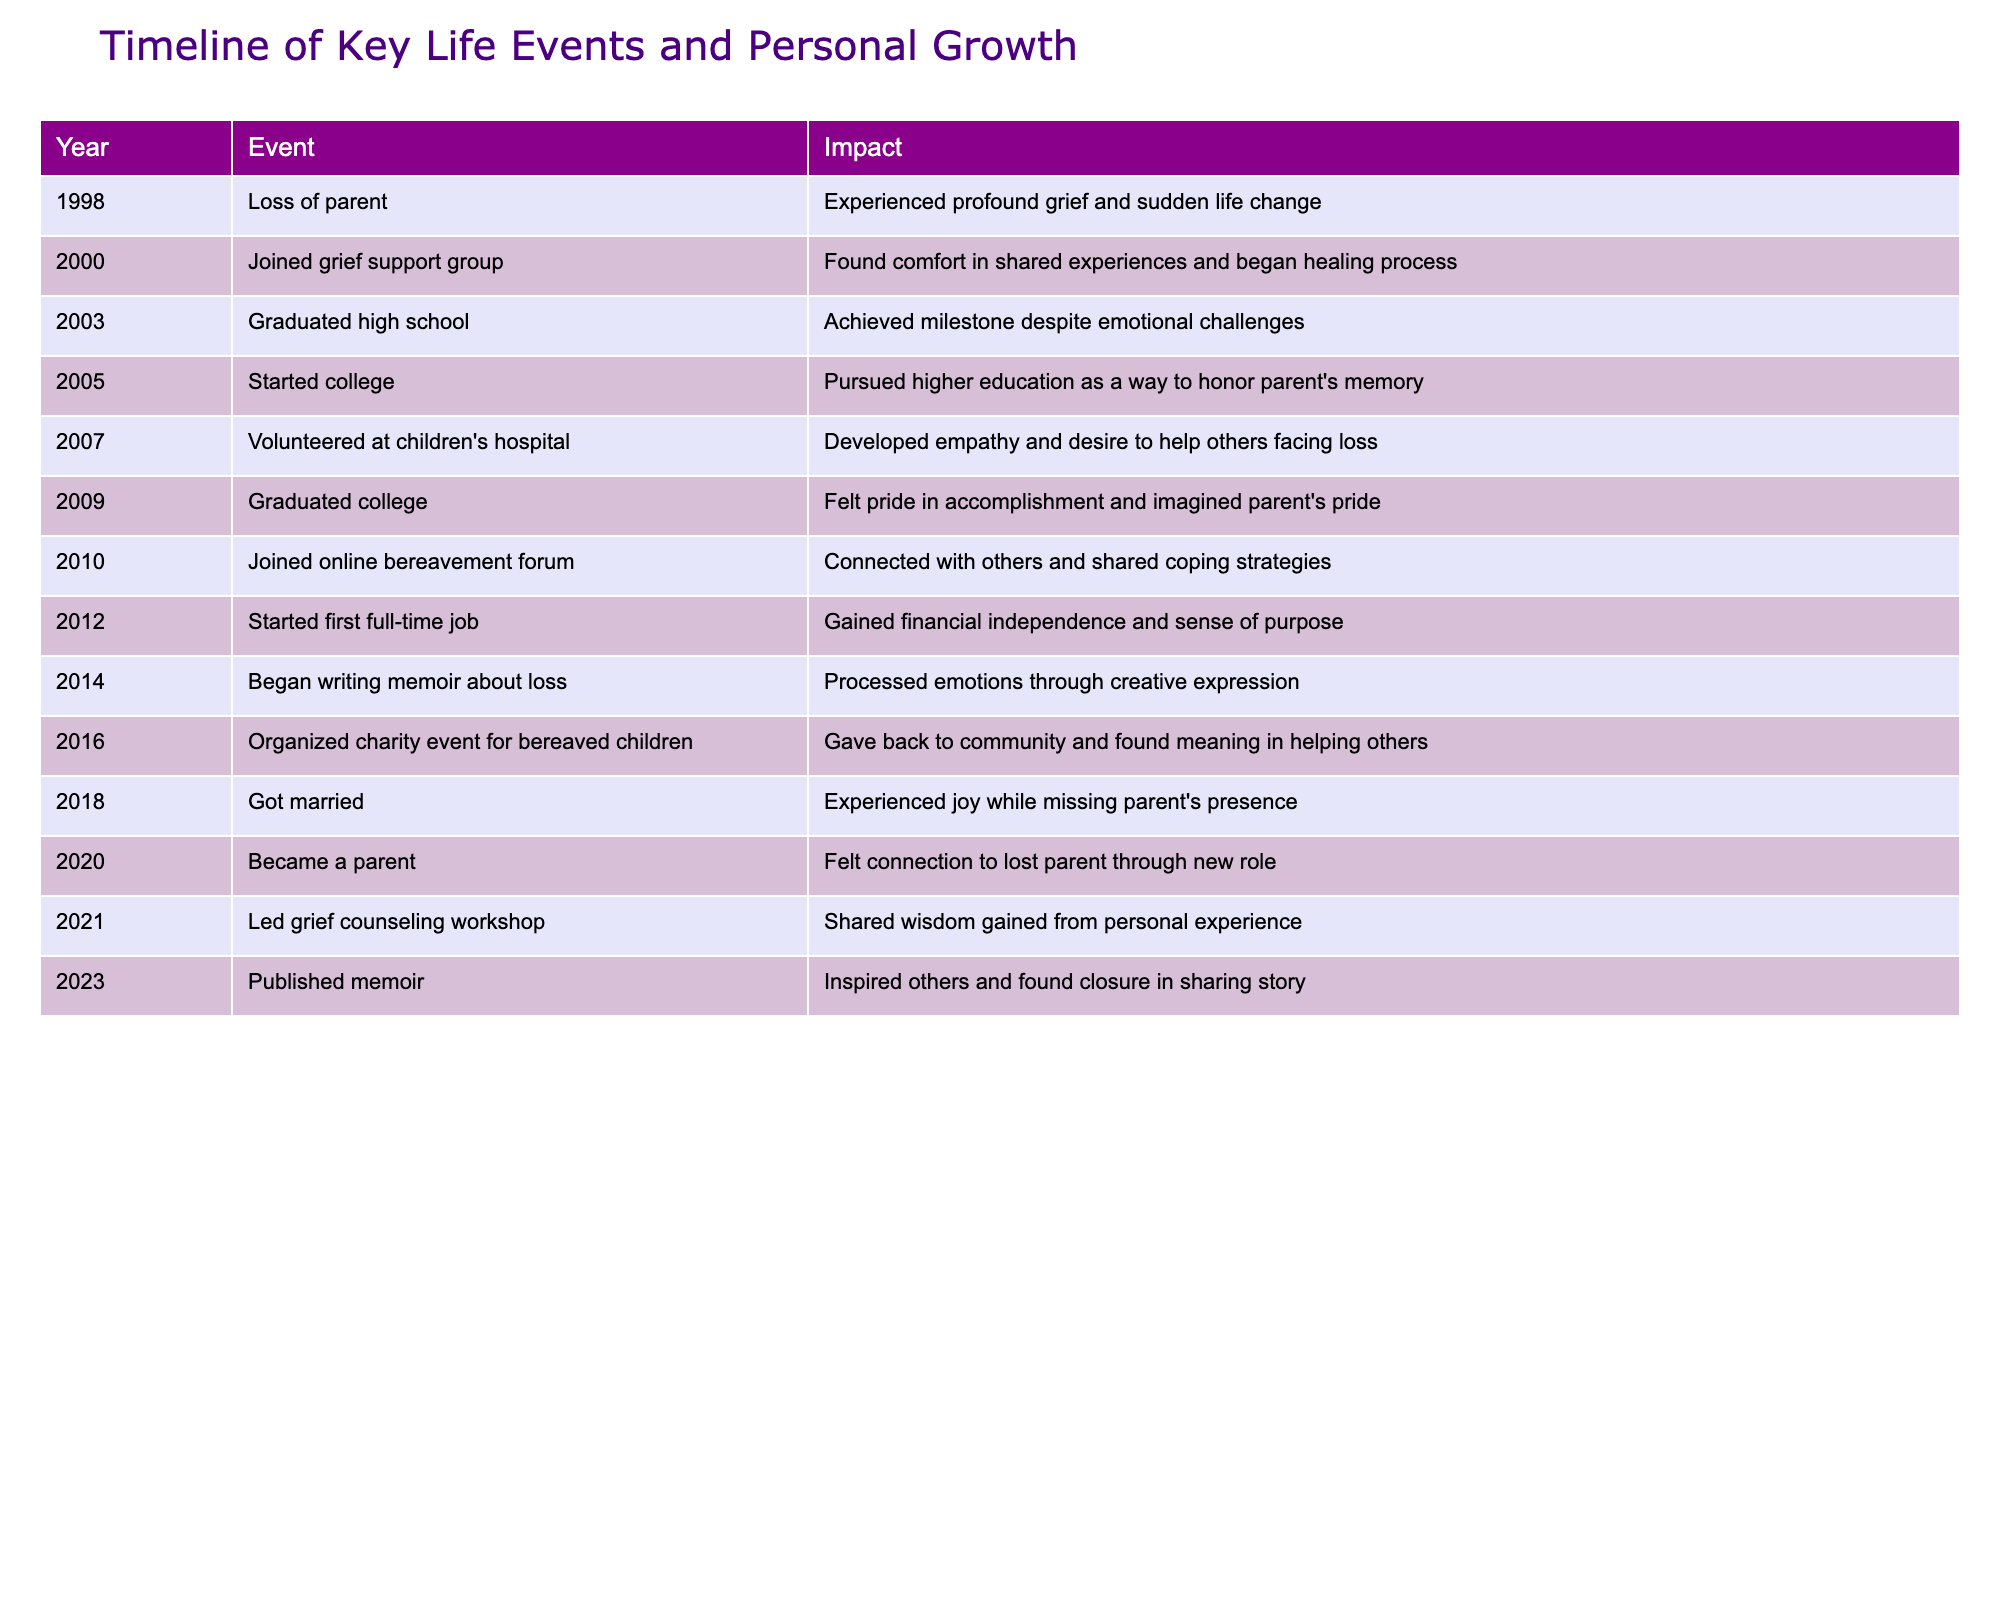What year did the individual join a grief support group? The table lists the event "Joined grief support group" under the year 2000.
Answer: 2000 What was the impact of graduating college? According to the table, the impact of graduating college in 2009 was feeling pride in accomplishment and imagining the parent's pride.
Answer: Pride in accomplishment How many years passed between the loss of a parent and starting college? The individual lost their parent in 1998 and started college in 2005. Calculating the difference: 2005 - 1998 = 7 years.
Answer: 7 years Did the individual become a parent before or after publishing their memoir? The table shows that the individual became a parent in 2020 and published their memoir in 2023, indicating that they became a parent before publishing.
Answer: Before What were the major milestones that occurred between 2000 and 2010? The table indicates the following major milestones during this time: Joining the grief support group in 2000, graduating high school in 2003, and starting college in 2005, finishing with joining the online bereavement forum in 2010. These events reflect both educational and emotional growth.
Answer: Four major milestones What is the difference in years between starting the first full-time job and getting married? The first full-time job started in 2012, and the marriage took place in 2018. The difference in years is 2018 - 2012 = 6 years.
Answer: 6 years Was the charity event organized before or after joining the online bereavement forum? The charity event is listed in 2016, while the online bereavement forum was joined in 2010, indicating that the charity event was organized after joining the forum.
Answer: After What personal growth step is associated with developing empathy? The event associated with developing empathy is volunteering at a children's hospital, which occurred in 2007 according to the table.
Answer: Volunteering at children's hospital How many events focused on community service or helping others are recorded in the table? Upon reviewing the table, the following events focus on community service: volunteering at a children's hospital in 2007 and organizing a charity event in 2016, totaling two specific events focused on helping others.
Answer: 2 events 